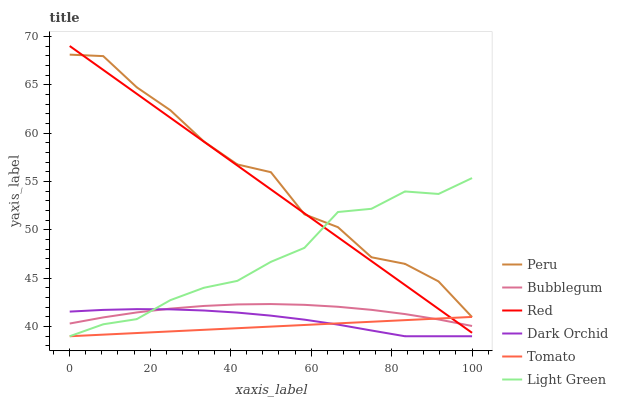Does Tomato have the minimum area under the curve?
Answer yes or no. Yes. Does Peru have the maximum area under the curve?
Answer yes or no. Yes. Does Dark Orchid have the minimum area under the curve?
Answer yes or no. No. Does Dark Orchid have the maximum area under the curve?
Answer yes or no. No. Is Red the smoothest?
Answer yes or no. Yes. Is Peru the roughest?
Answer yes or no. Yes. Is Dark Orchid the smoothest?
Answer yes or no. No. Is Dark Orchid the roughest?
Answer yes or no. No. Does Tomato have the lowest value?
Answer yes or no. Yes. Does Peru have the lowest value?
Answer yes or no. No. Does Red have the highest value?
Answer yes or no. Yes. Does Peru have the highest value?
Answer yes or no. No. Is Dark Orchid less than Peru?
Answer yes or no. Yes. Is Red greater than Dark Orchid?
Answer yes or no. Yes. Does Red intersect Light Green?
Answer yes or no. Yes. Is Red less than Light Green?
Answer yes or no. No. Is Red greater than Light Green?
Answer yes or no. No. Does Dark Orchid intersect Peru?
Answer yes or no. No. 